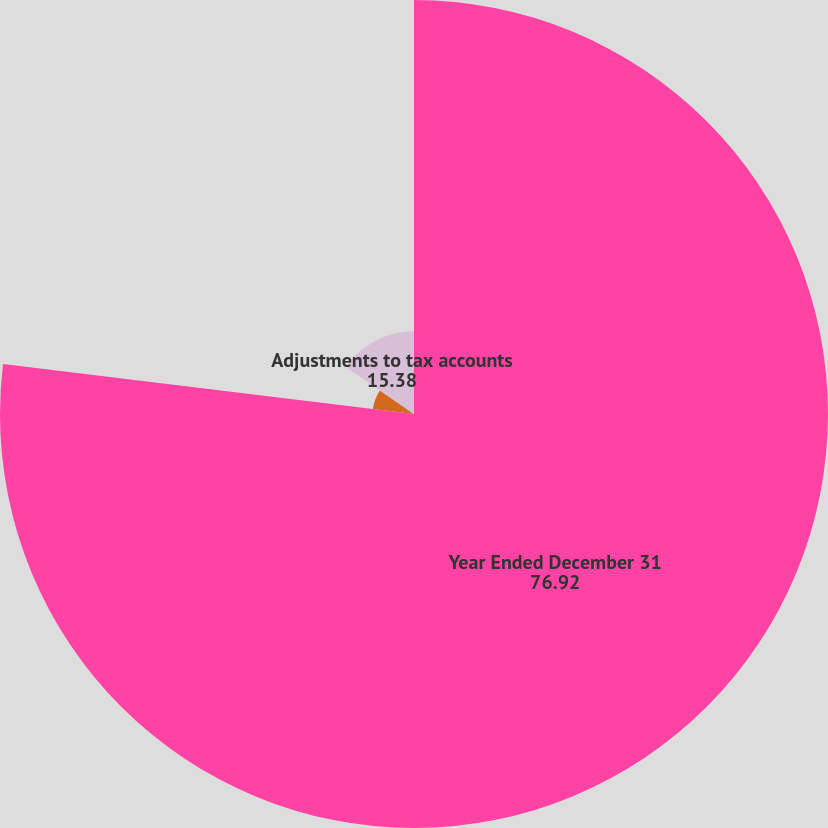<chart> <loc_0><loc_0><loc_500><loc_500><pie_chart><fcel>Year Ended December 31<fcel>Write-off of the excess<fcel>Adjustments to tax accounts<fcel>Total impact to earnings per<nl><fcel>76.92%<fcel>7.69%<fcel>15.38%<fcel>0.0%<nl></chart> 